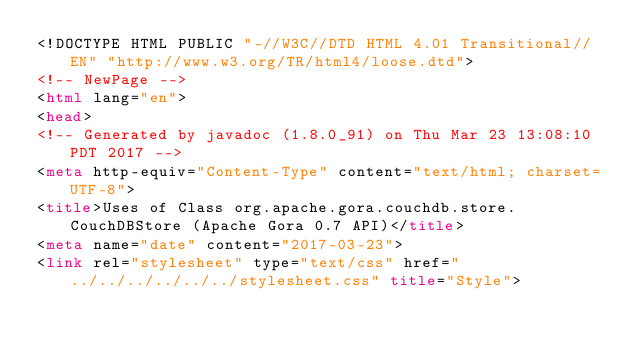Convert code to text. <code><loc_0><loc_0><loc_500><loc_500><_HTML_><!DOCTYPE HTML PUBLIC "-//W3C//DTD HTML 4.01 Transitional//EN" "http://www.w3.org/TR/html4/loose.dtd">
<!-- NewPage -->
<html lang="en">
<head>
<!-- Generated by javadoc (1.8.0_91) on Thu Mar 23 13:08:10 PDT 2017 -->
<meta http-equiv="Content-Type" content="text/html; charset=UTF-8">
<title>Uses of Class org.apache.gora.couchdb.store.CouchDBStore (Apache Gora 0.7 API)</title>
<meta name="date" content="2017-03-23">
<link rel="stylesheet" type="text/css" href="../../../../../../stylesheet.css" title="Style"></code> 